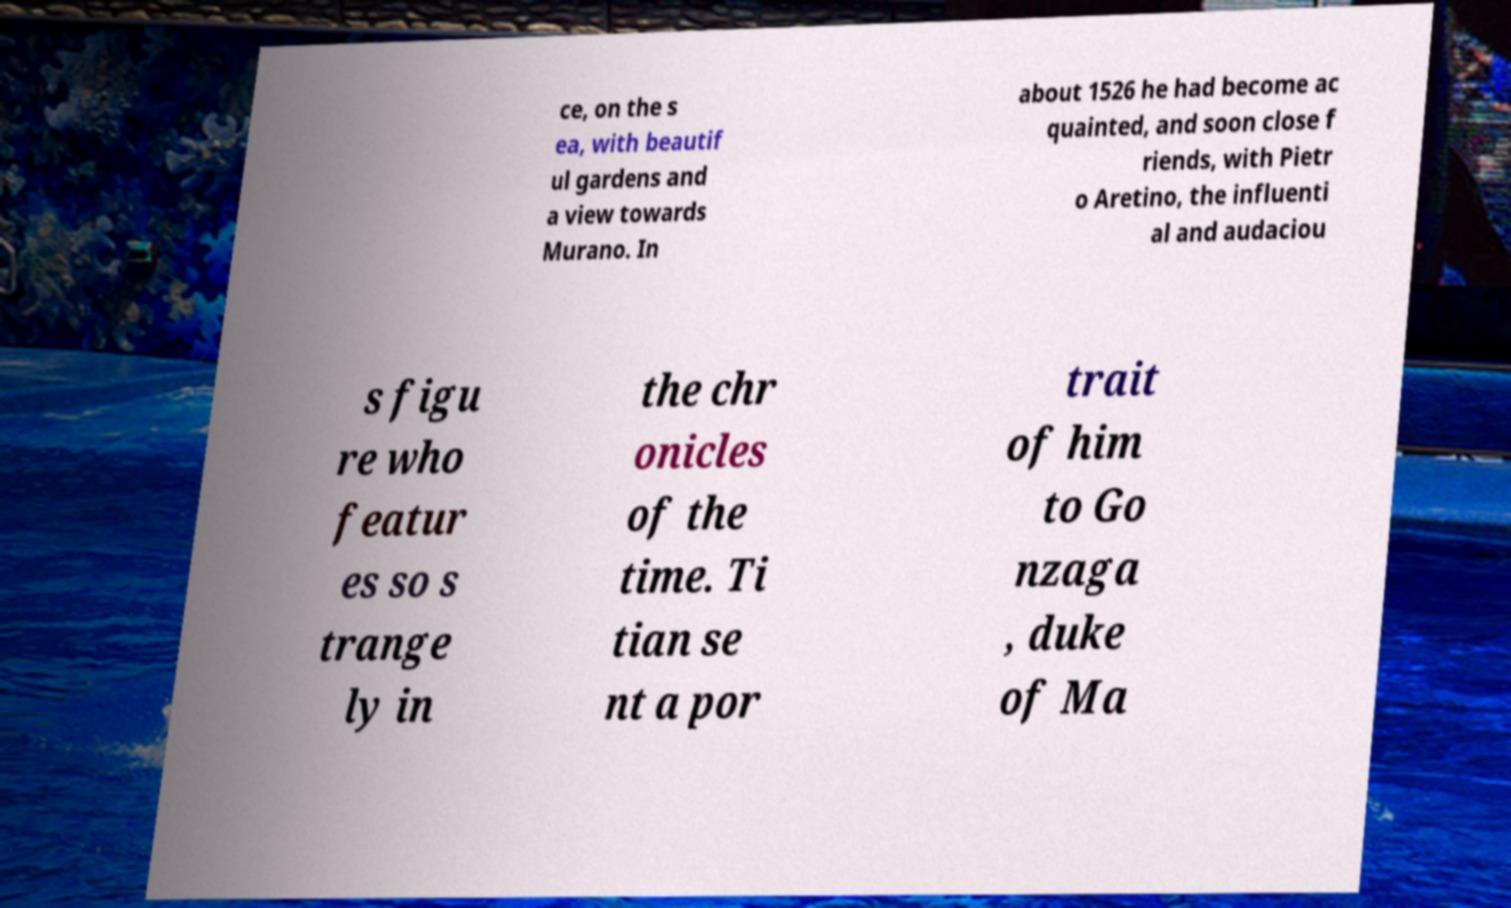Can you read and provide the text displayed in the image?This photo seems to have some interesting text. Can you extract and type it out for me? ce, on the s ea, with beautif ul gardens and a view towards Murano. In about 1526 he had become ac quainted, and soon close f riends, with Pietr o Aretino, the influenti al and audaciou s figu re who featur es so s trange ly in the chr onicles of the time. Ti tian se nt a por trait of him to Go nzaga , duke of Ma 